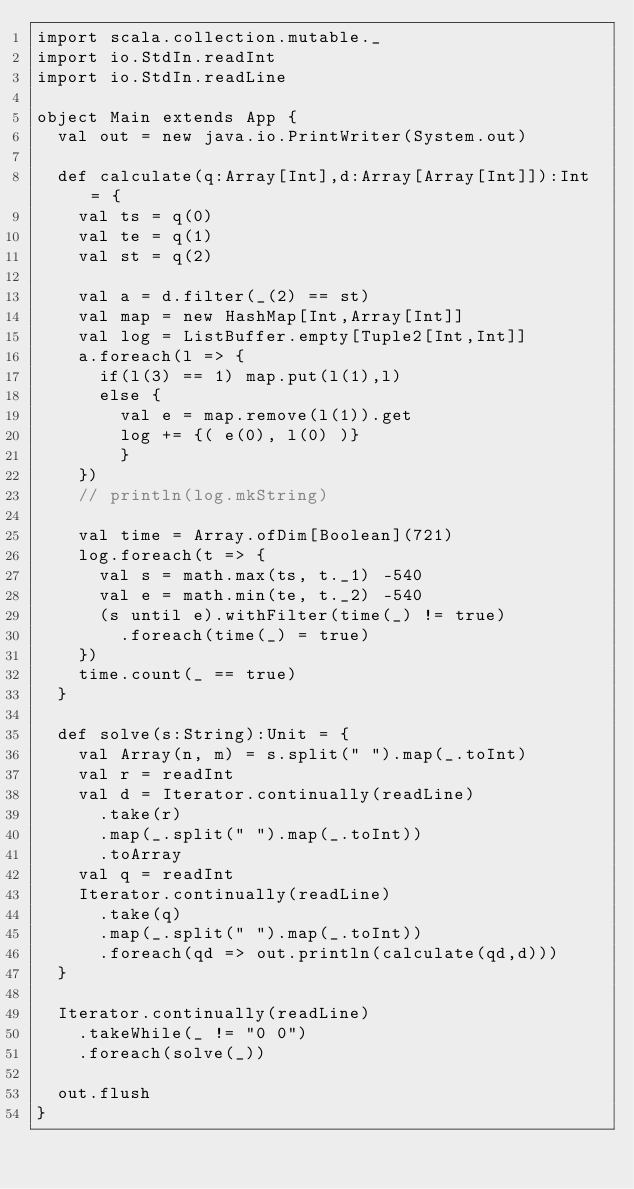<code> <loc_0><loc_0><loc_500><loc_500><_Scala_>import scala.collection.mutable._
import io.StdIn.readInt
import io.StdIn.readLine

object Main extends App {
  val out = new java.io.PrintWriter(System.out)

  def calculate(q:Array[Int],d:Array[Array[Int]]):Int = {
    val ts = q(0)
    val te = q(1)
    val st = q(2)

    val a = d.filter(_(2) == st)
    val map = new HashMap[Int,Array[Int]]
    val log = ListBuffer.empty[Tuple2[Int,Int]]
    a.foreach(l => {
      if(l(3) == 1) map.put(l(1),l)
      else {
        val e = map.remove(l(1)).get
        log += {( e(0), l(0) )}
        }
    })
    // println(log.mkString)

    val time = Array.ofDim[Boolean](721)
    log.foreach(t => {
      val s = math.max(ts, t._1) -540
      val e = math.min(te, t._2) -540
      (s until e).withFilter(time(_) != true)
        .foreach(time(_) = true)
    })
    time.count(_ == true)
  }

  def solve(s:String):Unit = {
    val Array(n, m) = s.split(" ").map(_.toInt)
    val r = readInt
    val d = Iterator.continually(readLine)
      .take(r)
      .map(_.split(" ").map(_.toInt))
      .toArray
    val q = readInt
    Iterator.continually(readLine)
      .take(q)
      .map(_.split(" ").map(_.toInt))
      .foreach(qd => out.println(calculate(qd,d)))
  }

  Iterator.continually(readLine)
    .takeWhile(_ != "0 0")
    .foreach(solve(_))
  
  out.flush
}
</code> 